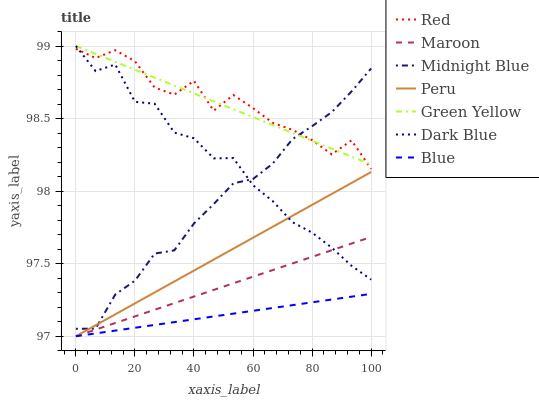Does Blue have the minimum area under the curve?
Answer yes or no. Yes. Does Red have the maximum area under the curve?
Answer yes or no. Yes. Does Midnight Blue have the minimum area under the curve?
Answer yes or no. No. Does Midnight Blue have the maximum area under the curve?
Answer yes or no. No. Is Maroon the smoothest?
Answer yes or no. Yes. Is Red the roughest?
Answer yes or no. Yes. Is Midnight Blue the smoothest?
Answer yes or no. No. Is Midnight Blue the roughest?
Answer yes or no. No. Does Blue have the lowest value?
Answer yes or no. Yes. Does Midnight Blue have the lowest value?
Answer yes or no. No. Does Green Yellow have the highest value?
Answer yes or no. Yes. Does Midnight Blue have the highest value?
Answer yes or no. No. Is Blue less than Midnight Blue?
Answer yes or no. Yes. Is Red greater than Blue?
Answer yes or no. Yes. Does Green Yellow intersect Dark Blue?
Answer yes or no. Yes. Is Green Yellow less than Dark Blue?
Answer yes or no. No. Is Green Yellow greater than Dark Blue?
Answer yes or no. No. Does Blue intersect Midnight Blue?
Answer yes or no. No. 